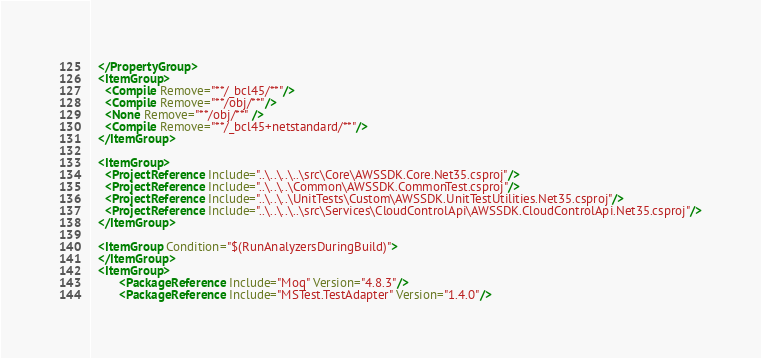<code> <loc_0><loc_0><loc_500><loc_500><_XML_>  </PropertyGroup>
  <ItemGroup>
    <Compile Remove="**/_bcl45/**"/>
    <Compile Remove="**/obj/**"/>
    <None Remove="**/obj/**" />
    <Compile Remove="**/_bcl45+netstandard/**"/>
  </ItemGroup>

  <ItemGroup>
    <ProjectReference Include="..\..\..\..\src\Core\AWSSDK.Core.Net35.csproj"/>
    <ProjectReference Include="..\..\..\Common\AWSSDK.CommonTest.csproj"/>
    <ProjectReference Include="..\..\..\UnitTests\Custom\AWSSDK.UnitTestUtilities.Net35.csproj"/>
    <ProjectReference Include="..\..\..\..\src\Services\CloudControlApi\AWSSDK.CloudControlApi.Net35.csproj"/>
  </ItemGroup>

  <ItemGroup Condition="$(RunAnalyzersDuringBuild)">
  </ItemGroup>
  <ItemGroup>
        <PackageReference Include="Moq" Version="4.8.3"/>
        <PackageReference Include="MSTest.TestAdapter" Version="1.4.0"/></code> 